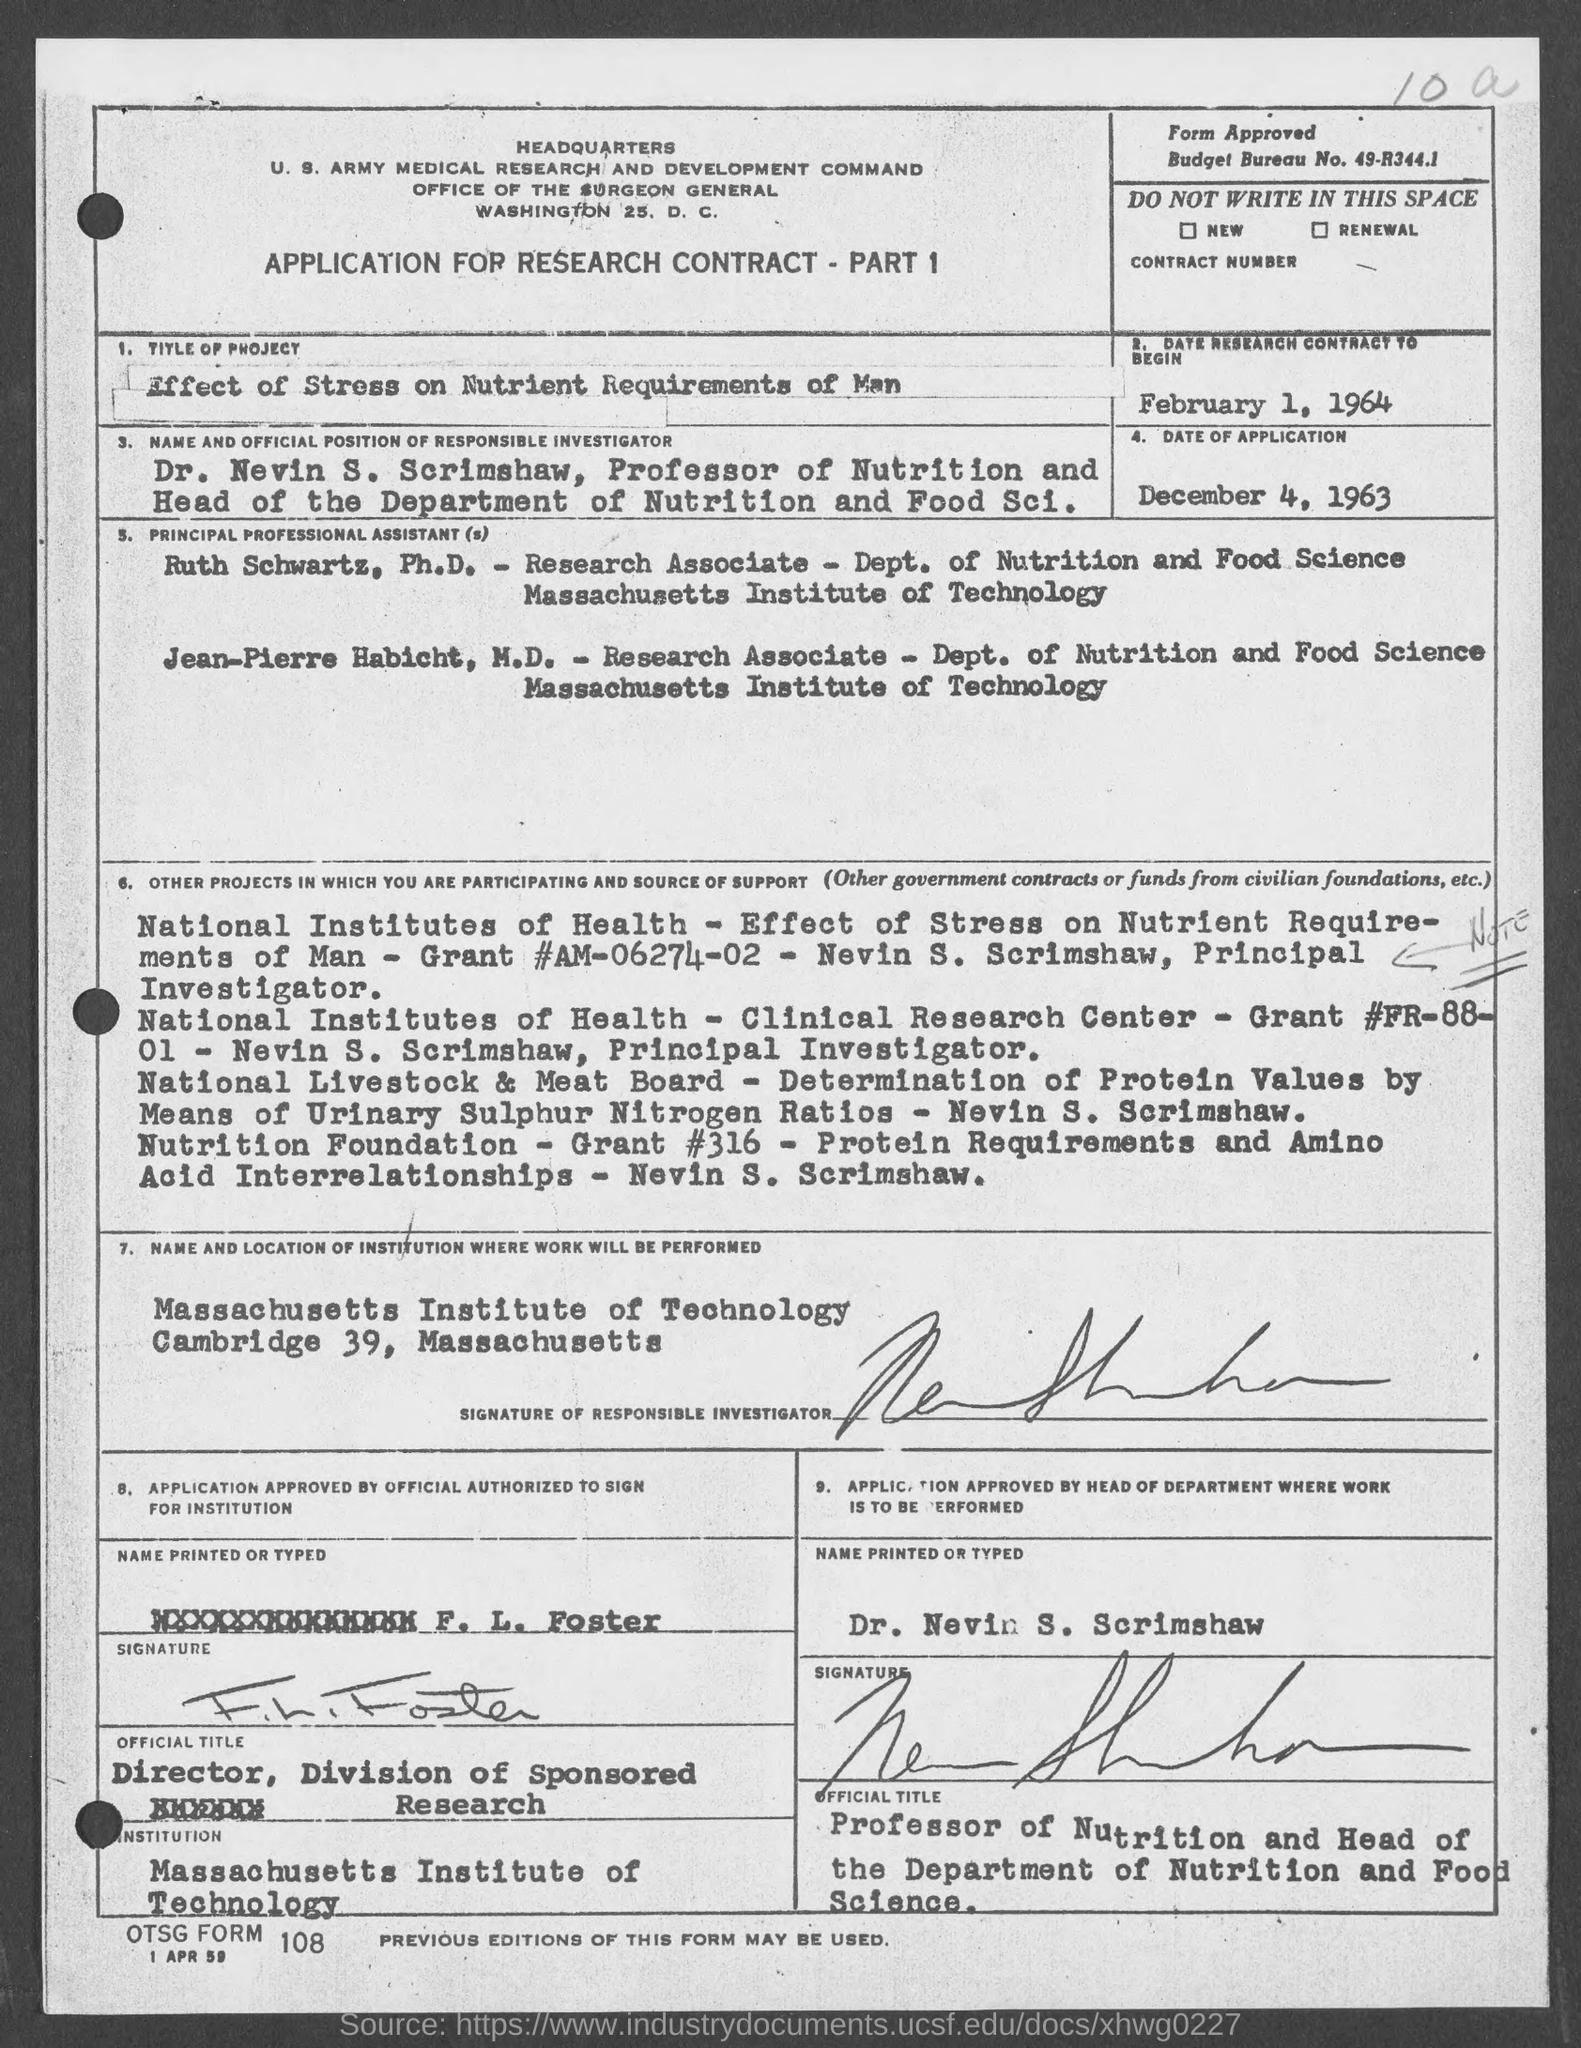What is the Budget bureau No.?
Keep it short and to the point. 49-R344.1. What is the date research contract to begin?
Ensure brevity in your answer.  February 1, 1964. When is the date of application?
Keep it short and to the point. December 4, 1963. What is the name of the head of the department?
Give a very brief answer. Dr. Nevin S. Scrimshaw. 